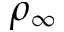<formula> <loc_0><loc_0><loc_500><loc_500>\rho _ { \infty }</formula> 